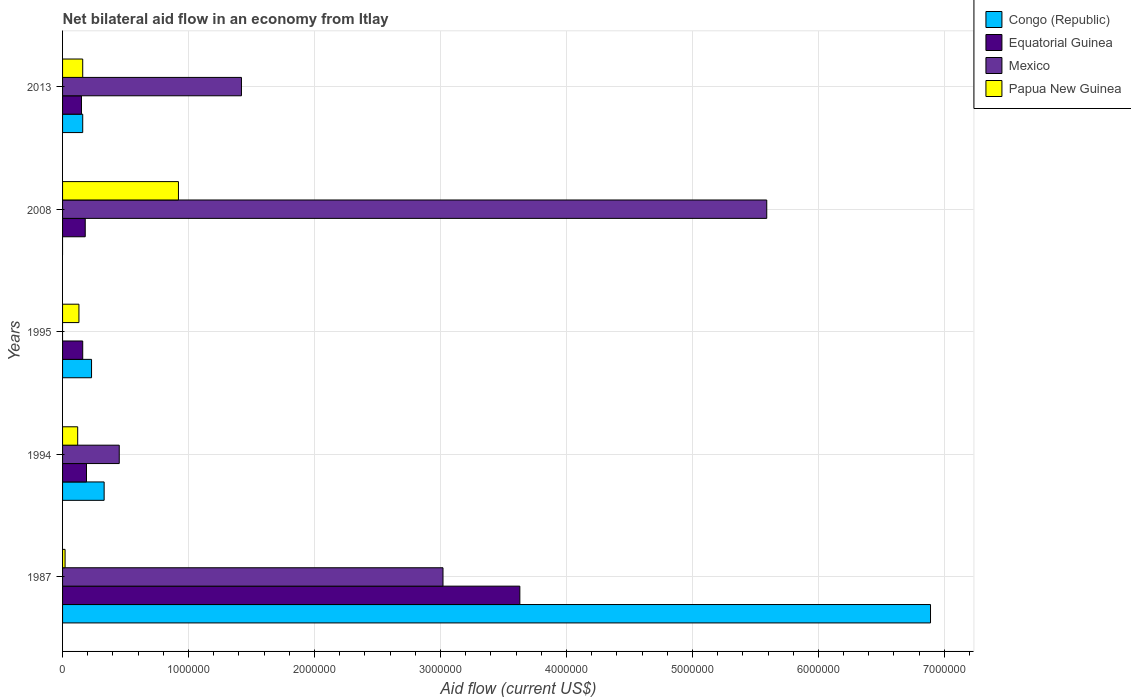Are the number of bars per tick equal to the number of legend labels?
Offer a terse response. No. Are the number of bars on each tick of the Y-axis equal?
Give a very brief answer. No. How many bars are there on the 5th tick from the top?
Provide a succinct answer. 4. What is the label of the 4th group of bars from the top?
Ensure brevity in your answer.  1994. In how many cases, is the number of bars for a given year not equal to the number of legend labels?
Keep it short and to the point. 2. What is the net bilateral aid flow in Congo (Republic) in 1994?
Make the answer very short. 3.30e+05. Across all years, what is the maximum net bilateral aid flow in Congo (Republic)?
Keep it short and to the point. 6.89e+06. What is the total net bilateral aid flow in Equatorial Guinea in the graph?
Provide a short and direct response. 4.31e+06. What is the difference between the net bilateral aid flow in Papua New Guinea in 1994 and that in 1995?
Your answer should be very brief. -10000. What is the difference between the net bilateral aid flow in Papua New Guinea in 1995 and the net bilateral aid flow in Equatorial Guinea in 2013?
Offer a terse response. -2.00e+04. What is the average net bilateral aid flow in Papua New Guinea per year?
Make the answer very short. 2.70e+05. In the year 2013, what is the difference between the net bilateral aid flow in Papua New Guinea and net bilateral aid flow in Mexico?
Keep it short and to the point. -1.26e+06. In how many years, is the net bilateral aid flow in Mexico greater than 2000000 US$?
Ensure brevity in your answer.  2. What is the ratio of the net bilateral aid flow in Equatorial Guinea in 2008 to that in 2013?
Make the answer very short. 1.2. Is the net bilateral aid flow in Papua New Guinea in 1994 less than that in 2013?
Make the answer very short. Yes. Is the difference between the net bilateral aid flow in Papua New Guinea in 1987 and 1994 greater than the difference between the net bilateral aid flow in Mexico in 1987 and 1994?
Make the answer very short. No. What is the difference between the highest and the second highest net bilateral aid flow in Mexico?
Ensure brevity in your answer.  2.57e+06. What is the difference between the highest and the lowest net bilateral aid flow in Congo (Republic)?
Keep it short and to the point. 6.89e+06. How many bars are there?
Ensure brevity in your answer.  18. Are the values on the major ticks of X-axis written in scientific E-notation?
Offer a terse response. No. Does the graph contain any zero values?
Offer a terse response. Yes. How many legend labels are there?
Offer a terse response. 4. How are the legend labels stacked?
Provide a short and direct response. Vertical. What is the title of the graph?
Your answer should be compact. Net bilateral aid flow in an economy from Itlay. Does "Canada" appear as one of the legend labels in the graph?
Your answer should be compact. No. What is the Aid flow (current US$) of Congo (Republic) in 1987?
Offer a very short reply. 6.89e+06. What is the Aid flow (current US$) of Equatorial Guinea in 1987?
Provide a succinct answer. 3.63e+06. What is the Aid flow (current US$) in Mexico in 1987?
Offer a very short reply. 3.02e+06. What is the Aid flow (current US$) of Papua New Guinea in 1987?
Provide a succinct answer. 2.00e+04. What is the Aid flow (current US$) of Papua New Guinea in 1994?
Your response must be concise. 1.20e+05. What is the Aid flow (current US$) of Equatorial Guinea in 1995?
Make the answer very short. 1.60e+05. What is the Aid flow (current US$) of Papua New Guinea in 1995?
Provide a succinct answer. 1.30e+05. What is the Aid flow (current US$) of Equatorial Guinea in 2008?
Keep it short and to the point. 1.80e+05. What is the Aid flow (current US$) in Mexico in 2008?
Give a very brief answer. 5.59e+06. What is the Aid flow (current US$) of Papua New Guinea in 2008?
Your answer should be compact. 9.20e+05. What is the Aid flow (current US$) in Equatorial Guinea in 2013?
Make the answer very short. 1.50e+05. What is the Aid flow (current US$) in Mexico in 2013?
Make the answer very short. 1.42e+06. Across all years, what is the maximum Aid flow (current US$) in Congo (Republic)?
Give a very brief answer. 6.89e+06. Across all years, what is the maximum Aid flow (current US$) in Equatorial Guinea?
Provide a succinct answer. 3.63e+06. Across all years, what is the maximum Aid flow (current US$) in Mexico?
Ensure brevity in your answer.  5.59e+06. Across all years, what is the maximum Aid flow (current US$) of Papua New Guinea?
Your response must be concise. 9.20e+05. Across all years, what is the minimum Aid flow (current US$) in Papua New Guinea?
Your answer should be very brief. 2.00e+04. What is the total Aid flow (current US$) of Congo (Republic) in the graph?
Your answer should be very brief. 7.61e+06. What is the total Aid flow (current US$) of Equatorial Guinea in the graph?
Your answer should be compact. 4.31e+06. What is the total Aid flow (current US$) in Mexico in the graph?
Your response must be concise. 1.05e+07. What is the total Aid flow (current US$) of Papua New Guinea in the graph?
Provide a short and direct response. 1.35e+06. What is the difference between the Aid flow (current US$) in Congo (Republic) in 1987 and that in 1994?
Keep it short and to the point. 6.56e+06. What is the difference between the Aid flow (current US$) of Equatorial Guinea in 1987 and that in 1994?
Your response must be concise. 3.44e+06. What is the difference between the Aid flow (current US$) of Mexico in 1987 and that in 1994?
Your response must be concise. 2.57e+06. What is the difference between the Aid flow (current US$) of Papua New Guinea in 1987 and that in 1994?
Keep it short and to the point. -1.00e+05. What is the difference between the Aid flow (current US$) of Congo (Republic) in 1987 and that in 1995?
Keep it short and to the point. 6.66e+06. What is the difference between the Aid flow (current US$) of Equatorial Guinea in 1987 and that in 1995?
Provide a short and direct response. 3.47e+06. What is the difference between the Aid flow (current US$) of Equatorial Guinea in 1987 and that in 2008?
Your answer should be compact. 3.45e+06. What is the difference between the Aid flow (current US$) in Mexico in 1987 and that in 2008?
Your answer should be compact. -2.57e+06. What is the difference between the Aid flow (current US$) of Papua New Guinea in 1987 and that in 2008?
Keep it short and to the point. -9.00e+05. What is the difference between the Aid flow (current US$) in Congo (Republic) in 1987 and that in 2013?
Ensure brevity in your answer.  6.73e+06. What is the difference between the Aid flow (current US$) of Equatorial Guinea in 1987 and that in 2013?
Keep it short and to the point. 3.48e+06. What is the difference between the Aid flow (current US$) of Mexico in 1987 and that in 2013?
Give a very brief answer. 1.60e+06. What is the difference between the Aid flow (current US$) in Congo (Republic) in 1994 and that in 1995?
Your response must be concise. 1.00e+05. What is the difference between the Aid flow (current US$) of Equatorial Guinea in 1994 and that in 1995?
Give a very brief answer. 3.00e+04. What is the difference between the Aid flow (current US$) in Papua New Guinea in 1994 and that in 1995?
Ensure brevity in your answer.  -10000. What is the difference between the Aid flow (current US$) in Mexico in 1994 and that in 2008?
Provide a short and direct response. -5.14e+06. What is the difference between the Aid flow (current US$) in Papua New Guinea in 1994 and that in 2008?
Provide a short and direct response. -8.00e+05. What is the difference between the Aid flow (current US$) in Congo (Republic) in 1994 and that in 2013?
Provide a succinct answer. 1.70e+05. What is the difference between the Aid flow (current US$) of Mexico in 1994 and that in 2013?
Provide a succinct answer. -9.70e+05. What is the difference between the Aid flow (current US$) of Papua New Guinea in 1994 and that in 2013?
Keep it short and to the point. -4.00e+04. What is the difference between the Aid flow (current US$) of Equatorial Guinea in 1995 and that in 2008?
Offer a terse response. -2.00e+04. What is the difference between the Aid flow (current US$) in Papua New Guinea in 1995 and that in 2008?
Provide a succinct answer. -7.90e+05. What is the difference between the Aid flow (current US$) in Congo (Republic) in 1995 and that in 2013?
Your answer should be compact. 7.00e+04. What is the difference between the Aid flow (current US$) in Papua New Guinea in 1995 and that in 2013?
Offer a terse response. -3.00e+04. What is the difference between the Aid flow (current US$) in Equatorial Guinea in 2008 and that in 2013?
Keep it short and to the point. 3.00e+04. What is the difference between the Aid flow (current US$) in Mexico in 2008 and that in 2013?
Your response must be concise. 4.17e+06. What is the difference between the Aid flow (current US$) in Papua New Guinea in 2008 and that in 2013?
Your answer should be very brief. 7.60e+05. What is the difference between the Aid flow (current US$) of Congo (Republic) in 1987 and the Aid flow (current US$) of Equatorial Guinea in 1994?
Make the answer very short. 6.70e+06. What is the difference between the Aid flow (current US$) of Congo (Republic) in 1987 and the Aid flow (current US$) of Mexico in 1994?
Offer a terse response. 6.44e+06. What is the difference between the Aid flow (current US$) of Congo (Republic) in 1987 and the Aid flow (current US$) of Papua New Guinea in 1994?
Give a very brief answer. 6.77e+06. What is the difference between the Aid flow (current US$) in Equatorial Guinea in 1987 and the Aid flow (current US$) in Mexico in 1994?
Offer a very short reply. 3.18e+06. What is the difference between the Aid flow (current US$) of Equatorial Guinea in 1987 and the Aid flow (current US$) of Papua New Guinea in 1994?
Your response must be concise. 3.51e+06. What is the difference between the Aid flow (current US$) of Mexico in 1987 and the Aid flow (current US$) of Papua New Guinea in 1994?
Your answer should be compact. 2.90e+06. What is the difference between the Aid flow (current US$) of Congo (Republic) in 1987 and the Aid flow (current US$) of Equatorial Guinea in 1995?
Keep it short and to the point. 6.73e+06. What is the difference between the Aid flow (current US$) in Congo (Republic) in 1987 and the Aid flow (current US$) in Papua New Guinea in 1995?
Make the answer very short. 6.76e+06. What is the difference between the Aid flow (current US$) in Equatorial Guinea in 1987 and the Aid flow (current US$) in Papua New Guinea in 1995?
Provide a succinct answer. 3.50e+06. What is the difference between the Aid flow (current US$) in Mexico in 1987 and the Aid flow (current US$) in Papua New Guinea in 1995?
Your answer should be very brief. 2.89e+06. What is the difference between the Aid flow (current US$) in Congo (Republic) in 1987 and the Aid flow (current US$) in Equatorial Guinea in 2008?
Your response must be concise. 6.71e+06. What is the difference between the Aid flow (current US$) of Congo (Republic) in 1987 and the Aid flow (current US$) of Mexico in 2008?
Ensure brevity in your answer.  1.30e+06. What is the difference between the Aid flow (current US$) in Congo (Republic) in 1987 and the Aid flow (current US$) in Papua New Guinea in 2008?
Provide a short and direct response. 5.97e+06. What is the difference between the Aid flow (current US$) in Equatorial Guinea in 1987 and the Aid flow (current US$) in Mexico in 2008?
Your answer should be compact. -1.96e+06. What is the difference between the Aid flow (current US$) in Equatorial Guinea in 1987 and the Aid flow (current US$) in Papua New Guinea in 2008?
Provide a succinct answer. 2.71e+06. What is the difference between the Aid flow (current US$) in Mexico in 1987 and the Aid flow (current US$) in Papua New Guinea in 2008?
Your response must be concise. 2.10e+06. What is the difference between the Aid flow (current US$) in Congo (Republic) in 1987 and the Aid flow (current US$) in Equatorial Guinea in 2013?
Your answer should be very brief. 6.74e+06. What is the difference between the Aid flow (current US$) of Congo (Republic) in 1987 and the Aid flow (current US$) of Mexico in 2013?
Provide a short and direct response. 5.47e+06. What is the difference between the Aid flow (current US$) of Congo (Republic) in 1987 and the Aid flow (current US$) of Papua New Guinea in 2013?
Offer a very short reply. 6.73e+06. What is the difference between the Aid flow (current US$) of Equatorial Guinea in 1987 and the Aid flow (current US$) of Mexico in 2013?
Provide a succinct answer. 2.21e+06. What is the difference between the Aid flow (current US$) of Equatorial Guinea in 1987 and the Aid flow (current US$) of Papua New Guinea in 2013?
Give a very brief answer. 3.47e+06. What is the difference between the Aid flow (current US$) of Mexico in 1987 and the Aid flow (current US$) of Papua New Guinea in 2013?
Keep it short and to the point. 2.86e+06. What is the difference between the Aid flow (current US$) of Congo (Republic) in 1994 and the Aid flow (current US$) of Papua New Guinea in 1995?
Your answer should be compact. 2.00e+05. What is the difference between the Aid flow (current US$) in Equatorial Guinea in 1994 and the Aid flow (current US$) in Papua New Guinea in 1995?
Your answer should be very brief. 6.00e+04. What is the difference between the Aid flow (current US$) of Congo (Republic) in 1994 and the Aid flow (current US$) of Mexico in 2008?
Your response must be concise. -5.26e+06. What is the difference between the Aid flow (current US$) of Congo (Republic) in 1994 and the Aid flow (current US$) of Papua New Guinea in 2008?
Provide a succinct answer. -5.90e+05. What is the difference between the Aid flow (current US$) of Equatorial Guinea in 1994 and the Aid flow (current US$) of Mexico in 2008?
Keep it short and to the point. -5.40e+06. What is the difference between the Aid flow (current US$) of Equatorial Guinea in 1994 and the Aid flow (current US$) of Papua New Guinea in 2008?
Your answer should be compact. -7.30e+05. What is the difference between the Aid flow (current US$) of Mexico in 1994 and the Aid flow (current US$) of Papua New Guinea in 2008?
Provide a short and direct response. -4.70e+05. What is the difference between the Aid flow (current US$) in Congo (Republic) in 1994 and the Aid flow (current US$) in Equatorial Guinea in 2013?
Offer a very short reply. 1.80e+05. What is the difference between the Aid flow (current US$) of Congo (Republic) in 1994 and the Aid flow (current US$) of Mexico in 2013?
Give a very brief answer. -1.09e+06. What is the difference between the Aid flow (current US$) of Equatorial Guinea in 1994 and the Aid flow (current US$) of Mexico in 2013?
Give a very brief answer. -1.23e+06. What is the difference between the Aid flow (current US$) in Equatorial Guinea in 1994 and the Aid flow (current US$) in Papua New Guinea in 2013?
Provide a succinct answer. 3.00e+04. What is the difference between the Aid flow (current US$) in Congo (Republic) in 1995 and the Aid flow (current US$) in Mexico in 2008?
Your answer should be very brief. -5.36e+06. What is the difference between the Aid flow (current US$) in Congo (Republic) in 1995 and the Aid flow (current US$) in Papua New Guinea in 2008?
Make the answer very short. -6.90e+05. What is the difference between the Aid flow (current US$) of Equatorial Guinea in 1995 and the Aid flow (current US$) of Mexico in 2008?
Give a very brief answer. -5.43e+06. What is the difference between the Aid flow (current US$) in Equatorial Guinea in 1995 and the Aid flow (current US$) in Papua New Guinea in 2008?
Your answer should be compact. -7.60e+05. What is the difference between the Aid flow (current US$) in Congo (Republic) in 1995 and the Aid flow (current US$) in Equatorial Guinea in 2013?
Make the answer very short. 8.00e+04. What is the difference between the Aid flow (current US$) of Congo (Republic) in 1995 and the Aid flow (current US$) of Mexico in 2013?
Offer a terse response. -1.19e+06. What is the difference between the Aid flow (current US$) of Congo (Republic) in 1995 and the Aid flow (current US$) of Papua New Guinea in 2013?
Give a very brief answer. 7.00e+04. What is the difference between the Aid flow (current US$) of Equatorial Guinea in 1995 and the Aid flow (current US$) of Mexico in 2013?
Your response must be concise. -1.26e+06. What is the difference between the Aid flow (current US$) in Equatorial Guinea in 1995 and the Aid flow (current US$) in Papua New Guinea in 2013?
Make the answer very short. 0. What is the difference between the Aid flow (current US$) of Equatorial Guinea in 2008 and the Aid flow (current US$) of Mexico in 2013?
Your answer should be very brief. -1.24e+06. What is the difference between the Aid flow (current US$) of Equatorial Guinea in 2008 and the Aid flow (current US$) of Papua New Guinea in 2013?
Your answer should be compact. 2.00e+04. What is the difference between the Aid flow (current US$) of Mexico in 2008 and the Aid flow (current US$) of Papua New Guinea in 2013?
Offer a terse response. 5.43e+06. What is the average Aid flow (current US$) in Congo (Republic) per year?
Keep it short and to the point. 1.52e+06. What is the average Aid flow (current US$) of Equatorial Guinea per year?
Keep it short and to the point. 8.62e+05. What is the average Aid flow (current US$) in Mexico per year?
Provide a short and direct response. 2.10e+06. In the year 1987, what is the difference between the Aid flow (current US$) in Congo (Republic) and Aid flow (current US$) in Equatorial Guinea?
Your answer should be very brief. 3.26e+06. In the year 1987, what is the difference between the Aid flow (current US$) of Congo (Republic) and Aid flow (current US$) of Mexico?
Ensure brevity in your answer.  3.87e+06. In the year 1987, what is the difference between the Aid flow (current US$) in Congo (Republic) and Aid flow (current US$) in Papua New Guinea?
Your answer should be compact. 6.87e+06. In the year 1987, what is the difference between the Aid flow (current US$) of Equatorial Guinea and Aid flow (current US$) of Mexico?
Make the answer very short. 6.10e+05. In the year 1987, what is the difference between the Aid flow (current US$) in Equatorial Guinea and Aid flow (current US$) in Papua New Guinea?
Your answer should be very brief. 3.61e+06. In the year 1994, what is the difference between the Aid flow (current US$) of Congo (Republic) and Aid flow (current US$) of Mexico?
Your answer should be compact. -1.20e+05. In the year 1994, what is the difference between the Aid flow (current US$) of Equatorial Guinea and Aid flow (current US$) of Mexico?
Offer a very short reply. -2.60e+05. In the year 1994, what is the difference between the Aid flow (current US$) of Mexico and Aid flow (current US$) of Papua New Guinea?
Provide a short and direct response. 3.30e+05. In the year 1995, what is the difference between the Aid flow (current US$) of Congo (Republic) and Aid flow (current US$) of Equatorial Guinea?
Provide a succinct answer. 7.00e+04. In the year 2008, what is the difference between the Aid flow (current US$) of Equatorial Guinea and Aid flow (current US$) of Mexico?
Your response must be concise. -5.41e+06. In the year 2008, what is the difference between the Aid flow (current US$) in Equatorial Guinea and Aid flow (current US$) in Papua New Guinea?
Your answer should be very brief. -7.40e+05. In the year 2008, what is the difference between the Aid flow (current US$) of Mexico and Aid flow (current US$) of Papua New Guinea?
Your response must be concise. 4.67e+06. In the year 2013, what is the difference between the Aid flow (current US$) in Congo (Republic) and Aid flow (current US$) in Mexico?
Ensure brevity in your answer.  -1.26e+06. In the year 2013, what is the difference between the Aid flow (current US$) in Equatorial Guinea and Aid flow (current US$) in Mexico?
Offer a terse response. -1.27e+06. In the year 2013, what is the difference between the Aid flow (current US$) of Mexico and Aid flow (current US$) of Papua New Guinea?
Give a very brief answer. 1.26e+06. What is the ratio of the Aid flow (current US$) of Congo (Republic) in 1987 to that in 1994?
Your response must be concise. 20.88. What is the ratio of the Aid flow (current US$) of Equatorial Guinea in 1987 to that in 1994?
Provide a succinct answer. 19.11. What is the ratio of the Aid flow (current US$) in Mexico in 1987 to that in 1994?
Provide a succinct answer. 6.71. What is the ratio of the Aid flow (current US$) of Congo (Republic) in 1987 to that in 1995?
Your answer should be compact. 29.96. What is the ratio of the Aid flow (current US$) of Equatorial Guinea in 1987 to that in 1995?
Make the answer very short. 22.69. What is the ratio of the Aid flow (current US$) in Papua New Guinea in 1987 to that in 1995?
Ensure brevity in your answer.  0.15. What is the ratio of the Aid flow (current US$) in Equatorial Guinea in 1987 to that in 2008?
Provide a short and direct response. 20.17. What is the ratio of the Aid flow (current US$) in Mexico in 1987 to that in 2008?
Your answer should be compact. 0.54. What is the ratio of the Aid flow (current US$) in Papua New Guinea in 1987 to that in 2008?
Make the answer very short. 0.02. What is the ratio of the Aid flow (current US$) in Congo (Republic) in 1987 to that in 2013?
Provide a short and direct response. 43.06. What is the ratio of the Aid flow (current US$) of Equatorial Guinea in 1987 to that in 2013?
Make the answer very short. 24.2. What is the ratio of the Aid flow (current US$) in Mexico in 1987 to that in 2013?
Your answer should be very brief. 2.13. What is the ratio of the Aid flow (current US$) in Papua New Guinea in 1987 to that in 2013?
Offer a terse response. 0.12. What is the ratio of the Aid flow (current US$) in Congo (Republic) in 1994 to that in 1995?
Offer a terse response. 1.43. What is the ratio of the Aid flow (current US$) of Equatorial Guinea in 1994 to that in 1995?
Ensure brevity in your answer.  1.19. What is the ratio of the Aid flow (current US$) of Papua New Guinea in 1994 to that in 1995?
Your answer should be very brief. 0.92. What is the ratio of the Aid flow (current US$) in Equatorial Guinea in 1994 to that in 2008?
Give a very brief answer. 1.06. What is the ratio of the Aid flow (current US$) in Mexico in 1994 to that in 2008?
Offer a very short reply. 0.08. What is the ratio of the Aid flow (current US$) of Papua New Guinea in 1994 to that in 2008?
Your response must be concise. 0.13. What is the ratio of the Aid flow (current US$) of Congo (Republic) in 1994 to that in 2013?
Offer a terse response. 2.06. What is the ratio of the Aid flow (current US$) in Equatorial Guinea in 1994 to that in 2013?
Provide a succinct answer. 1.27. What is the ratio of the Aid flow (current US$) of Mexico in 1994 to that in 2013?
Your answer should be compact. 0.32. What is the ratio of the Aid flow (current US$) of Papua New Guinea in 1994 to that in 2013?
Your answer should be compact. 0.75. What is the ratio of the Aid flow (current US$) in Equatorial Guinea in 1995 to that in 2008?
Your response must be concise. 0.89. What is the ratio of the Aid flow (current US$) in Papua New Guinea in 1995 to that in 2008?
Offer a very short reply. 0.14. What is the ratio of the Aid flow (current US$) in Congo (Republic) in 1995 to that in 2013?
Your response must be concise. 1.44. What is the ratio of the Aid flow (current US$) of Equatorial Guinea in 1995 to that in 2013?
Your response must be concise. 1.07. What is the ratio of the Aid flow (current US$) of Papua New Guinea in 1995 to that in 2013?
Provide a succinct answer. 0.81. What is the ratio of the Aid flow (current US$) of Equatorial Guinea in 2008 to that in 2013?
Offer a terse response. 1.2. What is the ratio of the Aid flow (current US$) of Mexico in 2008 to that in 2013?
Keep it short and to the point. 3.94. What is the ratio of the Aid flow (current US$) of Papua New Guinea in 2008 to that in 2013?
Make the answer very short. 5.75. What is the difference between the highest and the second highest Aid flow (current US$) of Congo (Republic)?
Ensure brevity in your answer.  6.56e+06. What is the difference between the highest and the second highest Aid flow (current US$) of Equatorial Guinea?
Your answer should be compact. 3.44e+06. What is the difference between the highest and the second highest Aid flow (current US$) in Mexico?
Your answer should be very brief. 2.57e+06. What is the difference between the highest and the second highest Aid flow (current US$) of Papua New Guinea?
Ensure brevity in your answer.  7.60e+05. What is the difference between the highest and the lowest Aid flow (current US$) of Congo (Republic)?
Your response must be concise. 6.89e+06. What is the difference between the highest and the lowest Aid flow (current US$) of Equatorial Guinea?
Provide a succinct answer. 3.48e+06. What is the difference between the highest and the lowest Aid flow (current US$) in Mexico?
Your answer should be compact. 5.59e+06. 